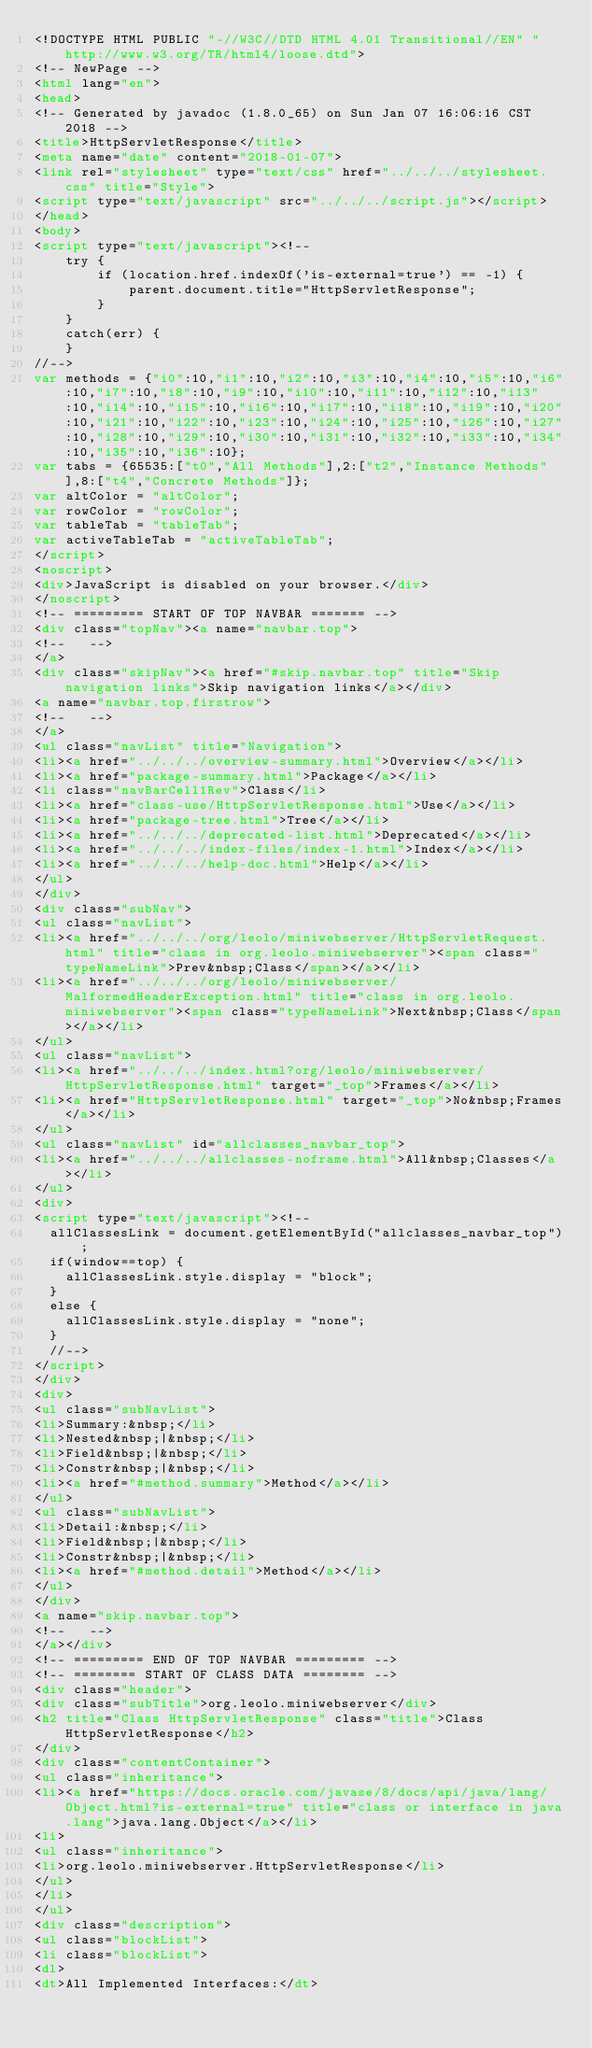Convert code to text. <code><loc_0><loc_0><loc_500><loc_500><_HTML_><!DOCTYPE HTML PUBLIC "-//W3C//DTD HTML 4.01 Transitional//EN" "http://www.w3.org/TR/html4/loose.dtd">
<!-- NewPage -->
<html lang="en">
<head>
<!-- Generated by javadoc (1.8.0_65) on Sun Jan 07 16:06:16 CST 2018 -->
<title>HttpServletResponse</title>
<meta name="date" content="2018-01-07">
<link rel="stylesheet" type="text/css" href="../../../stylesheet.css" title="Style">
<script type="text/javascript" src="../../../script.js"></script>
</head>
<body>
<script type="text/javascript"><!--
    try {
        if (location.href.indexOf('is-external=true') == -1) {
            parent.document.title="HttpServletResponse";
        }
    }
    catch(err) {
    }
//-->
var methods = {"i0":10,"i1":10,"i2":10,"i3":10,"i4":10,"i5":10,"i6":10,"i7":10,"i8":10,"i9":10,"i10":10,"i11":10,"i12":10,"i13":10,"i14":10,"i15":10,"i16":10,"i17":10,"i18":10,"i19":10,"i20":10,"i21":10,"i22":10,"i23":10,"i24":10,"i25":10,"i26":10,"i27":10,"i28":10,"i29":10,"i30":10,"i31":10,"i32":10,"i33":10,"i34":10,"i35":10,"i36":10};
var tabs = {65535:["t0","All Methods"],2:["t2","Instance Methods"],8:["t4","Concrete Methods"]};
var altColor = "altColor";
var rowColor = "rowColor";
var tableTab = "tableTab";
var activeTableTab = "activeTableTab";
</script>
<noscript>
<div>JavaScript is disabled on your browser.</div>
</noscript>
<!-- ========= START OF TOP NAVBAR ======= -->
<div class="topNav"><a name="navbar.top">
<!--   -->
</a>
<div class="skipNav"><a href="#skip.navbar.top" title="Skip navigation links">Skip navigation links</a></div>
<a name="navbar.top.firstrow">
<!--   -->
</a>
<ul class="navList" title="Navigation">
<li><a href="../../../overview-summary.html">Overview</a></li>
<li><a href="package-summary.html">Package</a></li>
<li class="navBarCell1Rev">Class</li>
<li><a href="class-use/HttpServletResponse.html">Use</a></li>
<li><a href="package-tree.html">Tree</a></li>
<li><a href="../../../deprecated-list.html">Deprecated</a></li>
<li><a href="../../../index-files/index-1.html">Index</a></li>
<li><a href="../../../help-doc.html">Help</a></li>
</ul>
</div>
<div class="subNav">
<ul class="navList">
<li><a href="../../../org/leolo/miniwebserver/HttpServletRequest.html" title="class in org.leolo.miniwebserver"><span class="typeNameLink">Prev&nbsp;Class</span></a></li>
<li><a href="../../../org/leolo/miniwebserver/MalformedHeaderException.html" title="class in org.leolo.miniwebserver"><span class="typeNameLink">Next&nbsp;Class</span></a></li>
</ul>
<ul class="navList">
<li><a href="../../../index.html?org/leolo/miniwebserver/HttpServletResponse.html" target="_top">Frames</a></li>
<li><a href="HttpServletResponse.html" target="_top">No&nbsp;Frames</a></li>
</ul>
<ul class="navList" id="allclasses_navbar_top">
<li><a href="../../../allclasses-noframe.html">All&nbsp;Classes</a></li>
</ul>
<div>
<script type="text/javascript"><!--
  allClassesLink = document.getElementById("allclasses_navbar_top");
  if(window==top) {
    allClassesLink.style.display = "block";
  }
  else {
    allClassesLink.style.display = "none";
  }
  //-->
</script>
</div>
<div>
<ul class="subNavList">
<li>Summary:&nbsp;</li>
<li>Nested&nbsp;|&nbsp;</li>
<li>Field&nbsp;|&nbsp;</li>
<li>Constr&nbsp;|&nbsp;</li>
<li><a href="#method.summary">Method</a></li>
</ul>
<ul class="subNavList">
<li>Detail:&nbsp;</li>
<li>Field&nbsp;|&nbsp;</li>
<li>Constr&nbsp;|&nbsp;</li>
<li><a href="#method.detail">Method</a></li>
</ul>
</div>
<a name="skip.navbar.top">
<!--   -->
</a></div>
<!-- ========= END OF TOP NAVBAR ========= -->
<!-- ======== START OF CLASS DATA ======== -->
<div class="header">
<div class="subTitle">org.leolo.miniwebserver</div>
<h2 title="Class HttpServletResponse" class="title">Class HttpServletResponse</h2>
</div>
<div class="contentContainer">
<ul class="inheritance">
<li><a href="https://docs.oracle.com/javase/8/docs/api/java/lang/Object.html?is-external=true" title="class or interface in java.lang">java.lang.Object</a></li>
<li>
<ul class="inheritance">
<li>org.leolo.miniwebserver.HttpServletResponse</li>
</ul>
</li>
</ul>
<div class="description">
<ul class="blockList">
<li class="blockList">
<dl>
<dt>All Implemented Interfaces:</dt></code> 